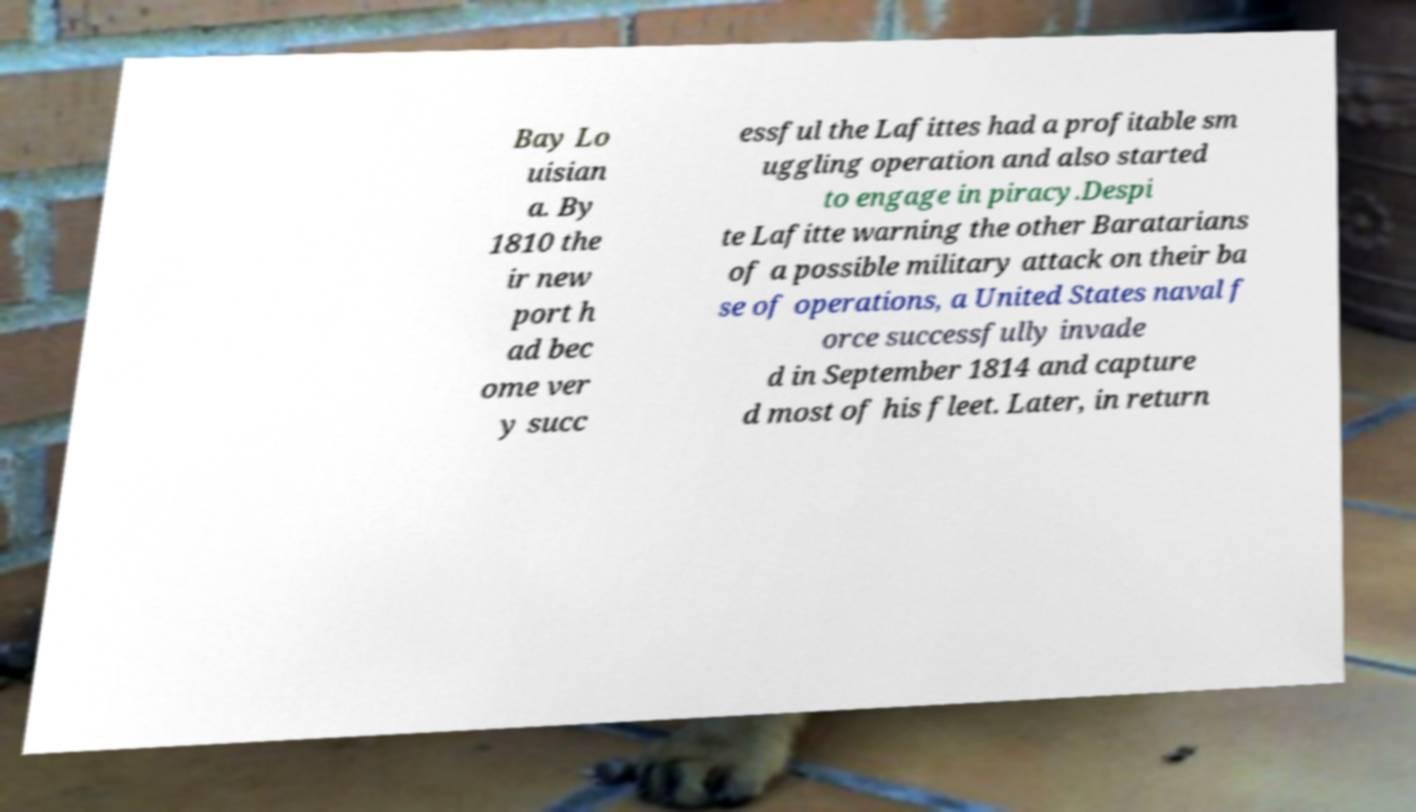I need the written content from this picture converted into text. Can you do that? Bay Lo uisian a. By 1810 the ir new port h ad bec ome ver y succ essful the Lafittes had a profitable sm uggling operation and also started to engage in piracy.Despi te Lafitte warning the other Baratarians of a possible military attack on their ba se of operations, a United States naval f orce successfully invade d in September 1814 and capture d most of his fleet. Later, in return 